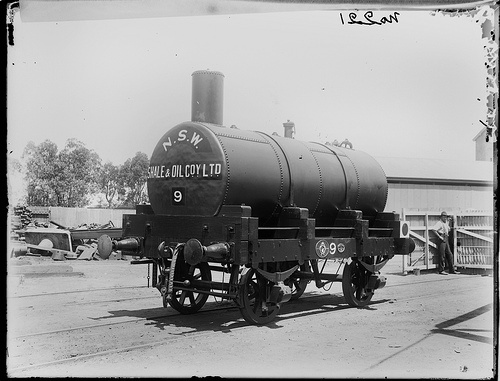Describe the objects in this image and their specific colors. I can see train in lightgray, black, gray, and darkgray tones and people in lightgray, black, gray, and darkgray tones in this image. 